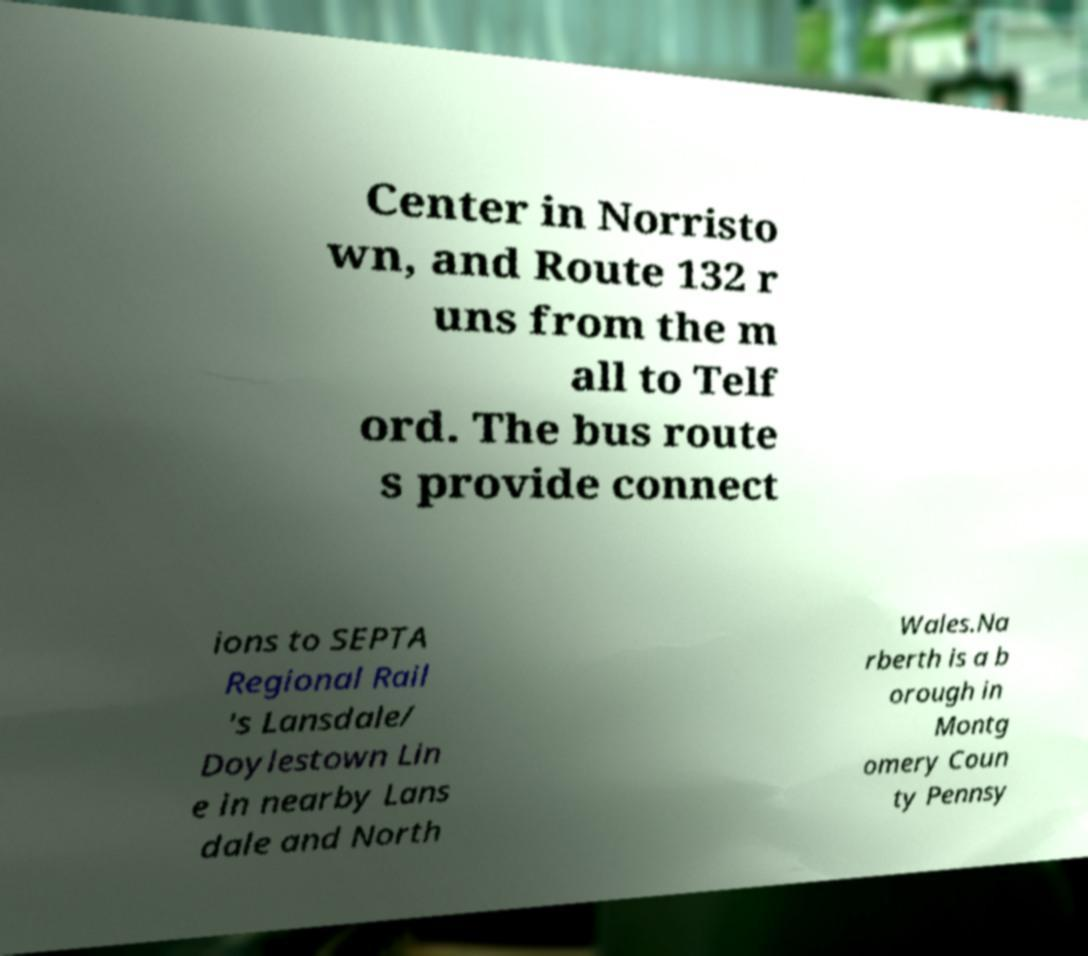Could you assist in decoding the text presented in this image and type it out clearly? Center in Norristo wn, and Route 132 r uns from the m all to Telf ord. The bus route s provide connect ions to SEPTA Regional Rail 's Lansdale/ Doylestown Lin e in nearby Lans dale and North Wales.Na rberth is a b orough in Montg omery Coun ty Pennsy 